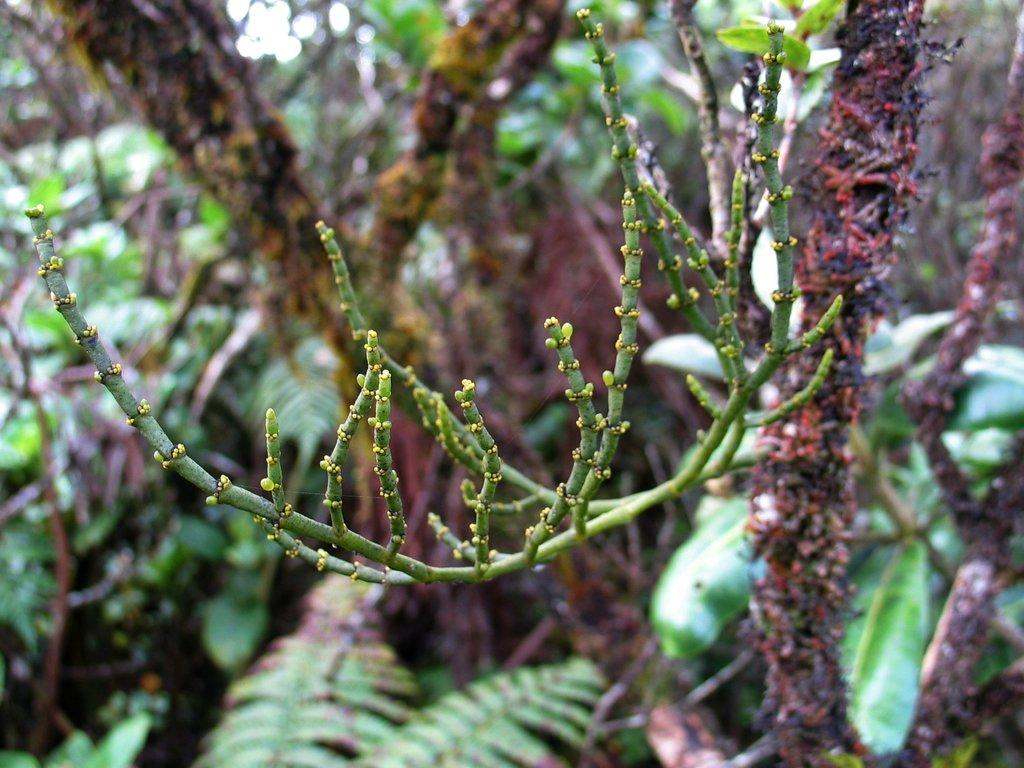What type of vegetation can be seen in the image? There are trees and plants in the image. Can you describe the background of the image? The background of the image is blurred. What language is your aunt speaking in the image? There is no aunt or spoken language present in the image. How many ears of corn can be seen in the image? There is no corn present in the image. 